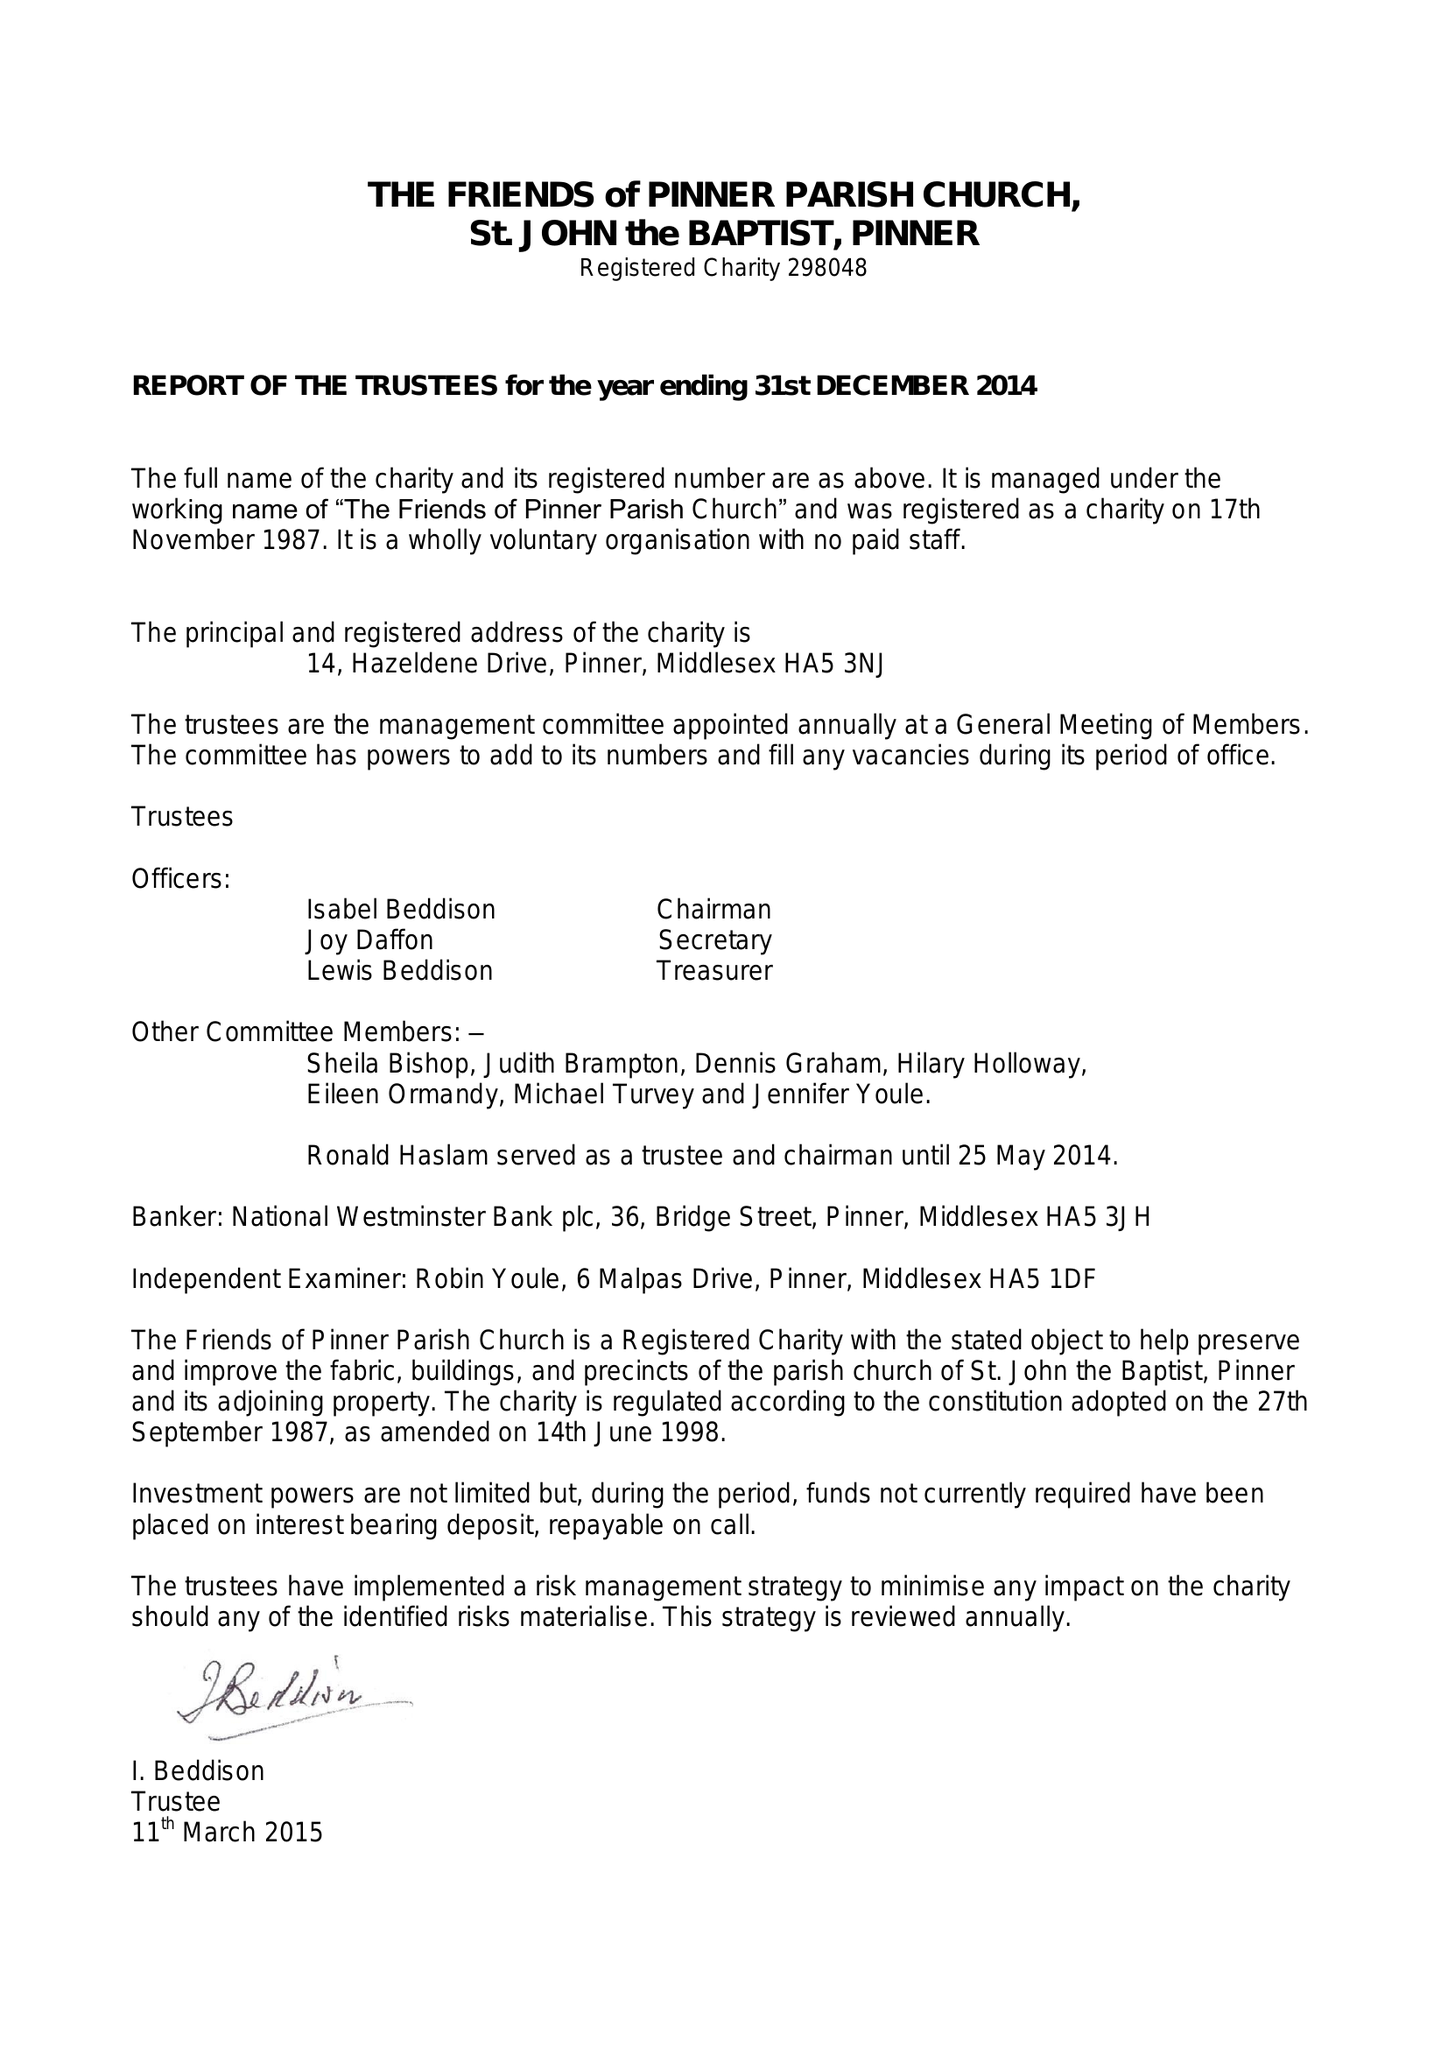What is the value for the charity_number?
Answer the question using a single word or phrase. 298048 